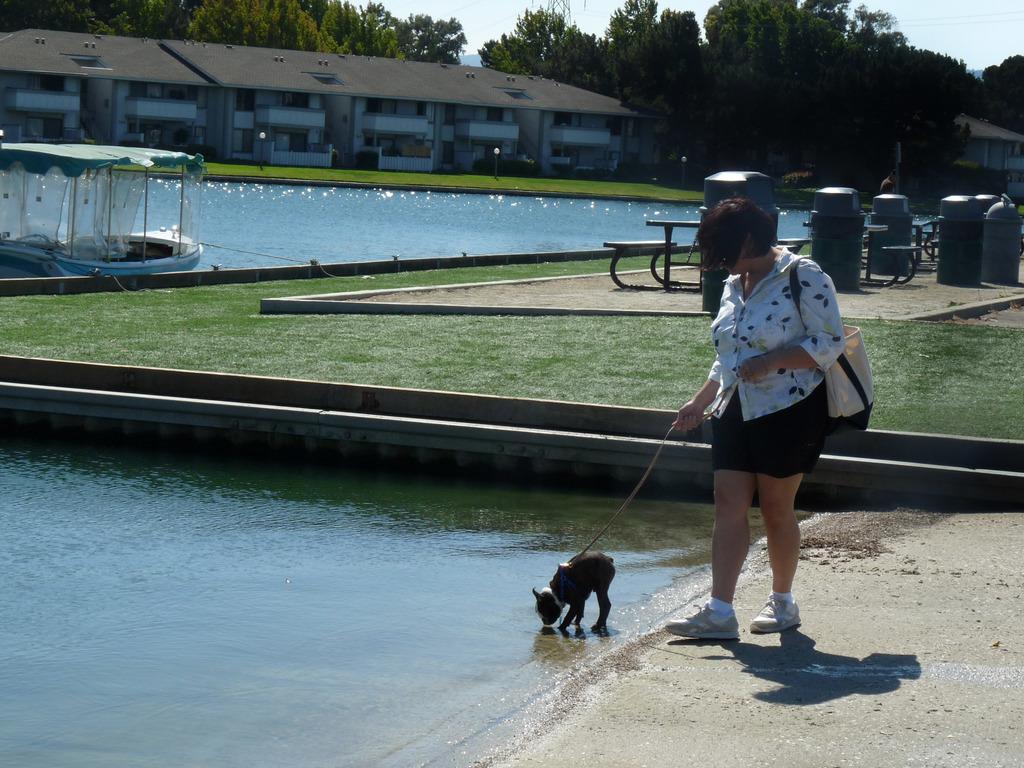Describe this image in one or two sentences. In this image I can see a person standing and holding a dog belt, the person is wearing white shirt, black short and the dog is in black color. Background I can see few benches and I can also see the water, background I can see a building, trees in green color and the sky is in white color. 